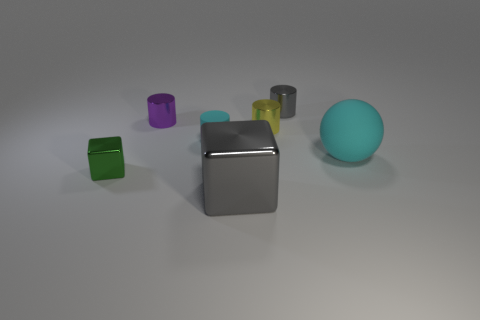How big is the purple metallic thing?
Your answer should be compact. Small. There is a tiny thing that is made of the same material as the cyan sphere; what color is it?
Make the answer very short. Cyan. How many cyan matte spheres have the same size as the gray cylinder?
Your answer should be compact. 0. Do the small object that is behind the purple metallic cylinder and the cyan ball have the same material?
Your answer should be compact. No. Is the number of small cylinders that are in front of the big gray shiny block less than the number of tiny purple things?
Provide a short and direct response. Yes. The cyan object that is right of the yellow metal cylinder has what shape?
Offer a terse response. Sphere. There is a matte thing that is the same size as the green cube; what is its shape?
Ensure brevity in your answer.  Cylinder. Is there a tiny cyan rubber object that has the same shape as the tiny gray metal object?
Keep it short and to the point. Yes. Does the small metallic object in front of the small rubber cylinder have the same shape as the gray metallic object that is in front of the small cyan object?
Give a very brief answer. Yes. What material is the cyan cylinder that is the same size as the purple thing?
Keep it short and to the point. Rubber. 